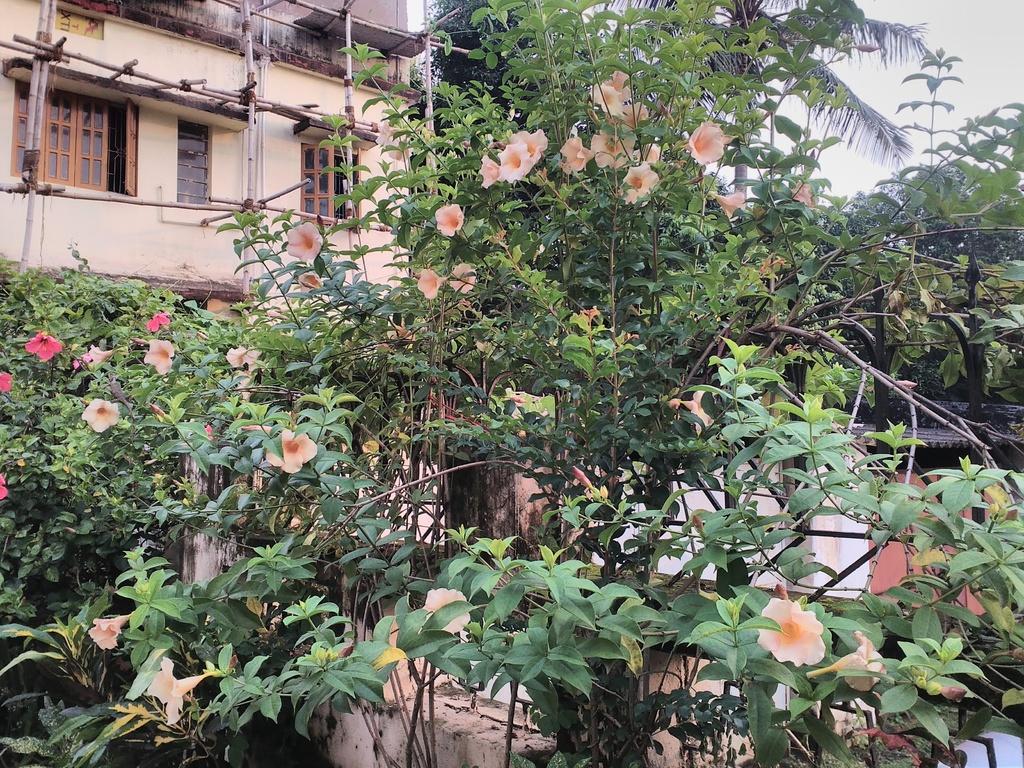Can you describe this image briefly? In this image we can see a building and it is having few windows. There are many trees and plants in the image. There are few objects in the image. There are many flowers to the plants. We can see the sky in the image. 